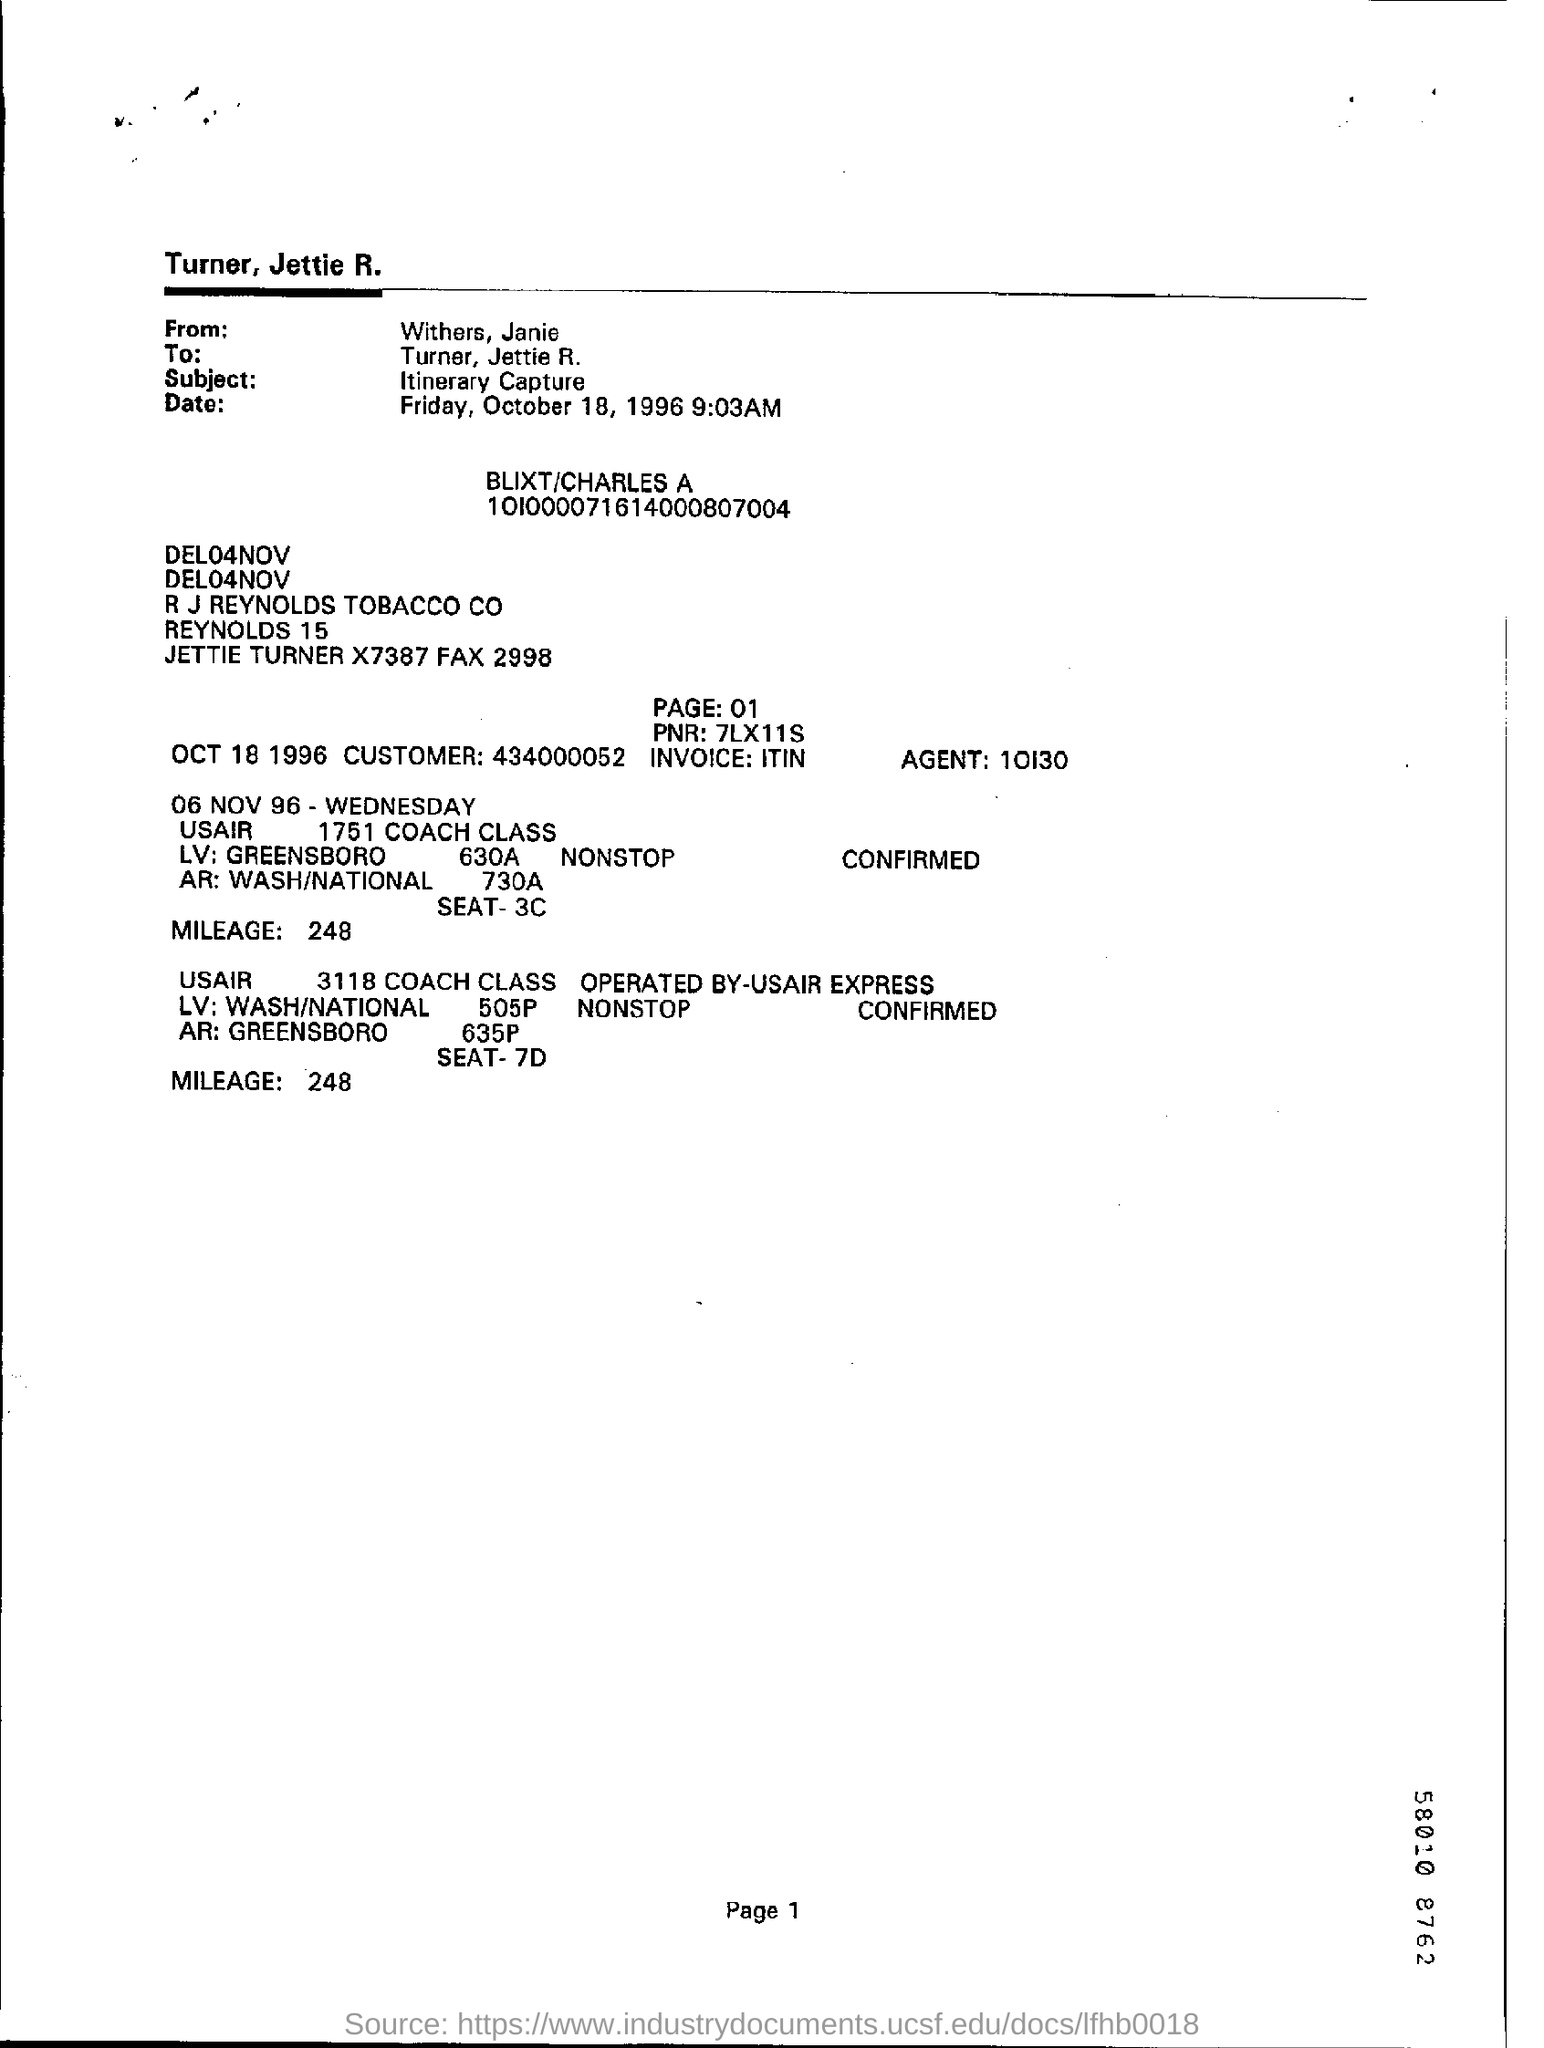Indicate a few pertinent items in this graphic. The PNR is a 7-digit number that is used to identify a train ticket reservation in India. The agent number is 10130...," the speaker declared. The mileage is 248. The author of this text is unclear, as the writing is from someone named Withers and Janie. It is recommended to mention the page number at the bottom of each page. 